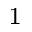<formula> <loc_0><loc_0><loc_500><loc_500>^ { 1 }</formula> 